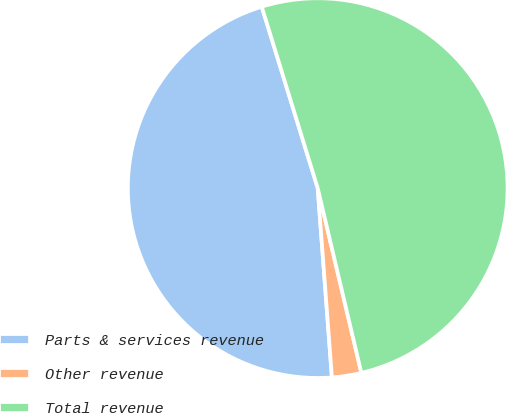<chart> <loc_0><loc_0><loc_500><loc_500><pie_chart><fcel>Parts & services revenue<fcel>Other revenue<fcel>Total revenue<nl><fcel>46.43%<fcel>2.5%<fcel>51.07%<nl></chart> 